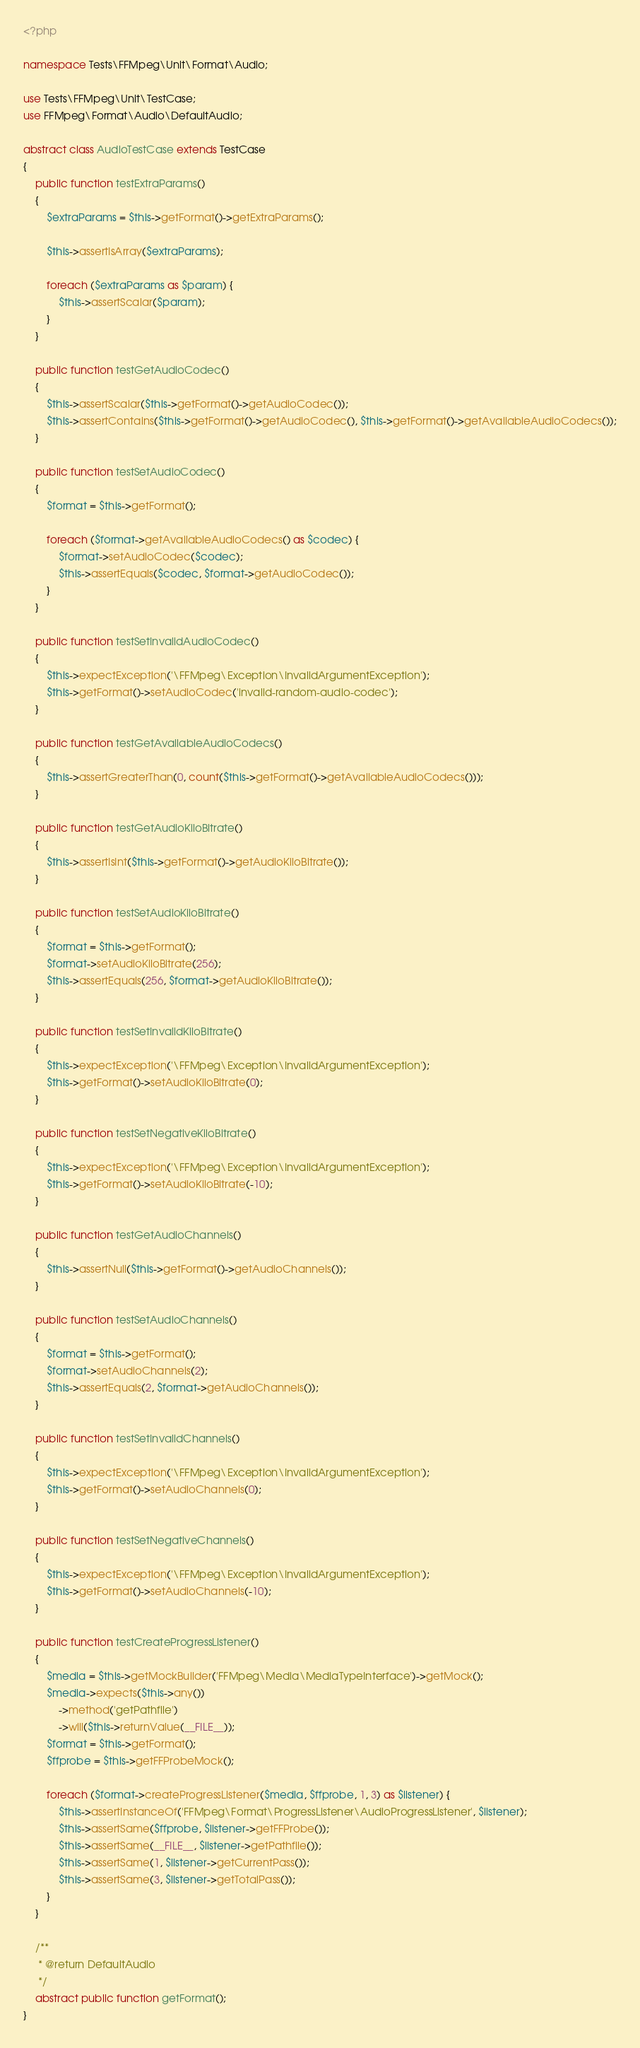Convert code to text. <code><loc_0><loc_0><loc_500><loc_500><_PHP_><?php

namespace Tests\FFMpeg\Unit\Format\Audio;

use Tests\FFMpeg\Unit\TestCase;
use FFMpeg\Format\Audio\DefaultAudio;

abstract class AudioTestCase extends TestCase
{
    public function testExtraParams()
    {
        $extraParams = $this->getFormat()->getExtraParams();

        $this->assertIsArray($extraParams);

        foreach ($extraParams as $param) {
            $this->assertScalar($param);
        }
    }

    public function testGetAudioCodec()
    {
        $this->assertScalar($this->getFormat()->getAudioCodec());
        $this->assertContains($this->getFormat()->getAudioCodec(), $this->getFormat()->getAvailableAudioCodecs());
    }

    public function testSetAudioCodec()
    {
        $format = $this->getFormat();

        foreach ($format->getAvailableAudioCodecs() as $codec) {
            $format->setAudioCodec($codec);
            $this->assertEquals($codec, $format->getAudioCodec());
        }
    }

    public function testSetInvalidAudioCodec()
    {
        $this->expectException('\FFMpeg\Exception\InvalidArgumentException');
        $this->getFormat()->setAudioCodec('invalid-random-audio-codec');
    }

    public function testGetAvailableAudioCodecs()
    {
        $this->assertGreaterThan(0, count($this->getFormat()->getAvailableAudioCodecs()));
    }

    public function testGetAudioKiloBitrate()
    {
        $this->assertIsInt($this->getFormat()->getAudioKiloBitrate());
    }

    public function testSetAudioKiloBitrate()
    {
        $format = $this->getFormat();
        $format->setAudioKiloBitrate(256);
        $this->assertEquals(256, $format->getAudioKiloBitrate());
    }

    public function testSetInvalidKiloBitrate()
    {
        $this->expectException('\FFMpeg\Exception\InvalidArgumentException');
        $this->getFormat()->setAudioKiloBitrate(0);
    }

    public function testSetNegativeKiloBitrate()
    {
        $this->expectException('\FFMpeg\Exception\InvalidArgumentException');
        $this->getFormat()->setAudioKiloBitrate(-10);
    }

    public function testGetAudioChannels()
    {
        $this->assertNull($this->getFormat()->getAudioChannels());
    }

    public function testSetAudioChannels()
    {
        $format = $this->getFormat();
        $format->setAudioChannels(2);
        $this->assertEquals(2, $format->getAudioChannels());
    }

    public function testSetInvalidChannels()
    {
        $this->expectException('\FFMpeg\Exception\InvalidArgumentException');
        $this->getFormat()->setAudioChannels(0);
    }

    public function testSetNegativeChannels()
    {
        $this->expectException('\FFMpeg\Exception\InvalidArgumentException');
        $this->getFormat()->setAudioChannels(-10);
    }

    public function testCreateProgressListener()
    {
        $media = $this->getMockBuilder('FFMpeg\Media\MediaTypeInterface')->getMock();
        $media->expects($this->any())
            ->method('getPathfile')
            ->will($this->returnValue(__FILE__));
        $format = $this->getFormat();
        $ffprobe = $this->getFFProbeMock();

        foreach ($format->createProgressListener($media, $ffprobe, 1, 3) as $listener) {
            $this->assertInstanceOf('FFMpeg\Format\ProgressListener\AudioProgressListener', $listener);
            $this->assertSame($ffprobe, $listener->getFFProbe());
            $this->assertSame(__FILE__, $listener->getPathfile());
            $this->assertSame(1, $listener->getCurrentPass());
            $this->assertSame(3, $listener->getTotalPass());
        }
    }

    /**
     * @return DefaultAudio
     */
    abstract public function getFormat();
}
</code> 